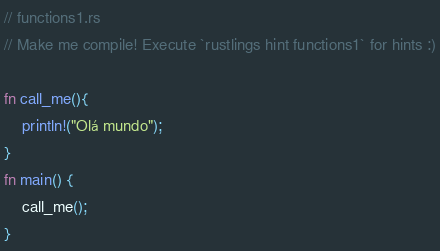<code> <loc_0><loc_0><loc_500><loc_500><_Rust_>// functions1.rs
// Make me compile! Execute `rustlings hint functions1` for hints :)

fn call_me(){
    println!("Olá mundo");
}
fn main() {
    call_me();
}
</code> 